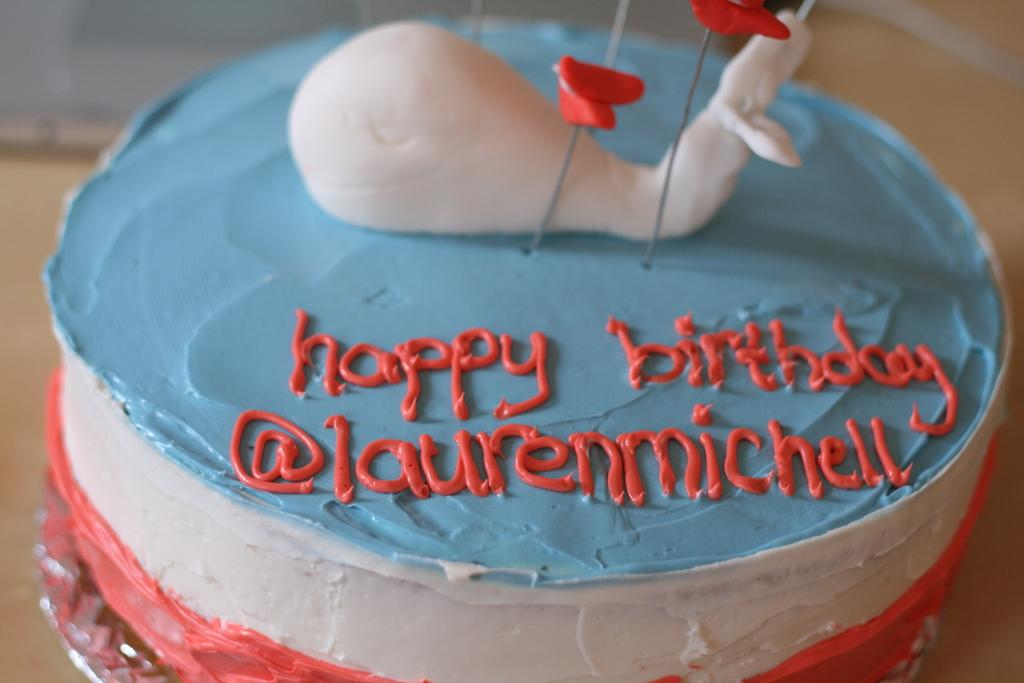What is the main subject of the image? There is a colorful cake in the image. How is the cake positioned in the image? The cake is on a platform. Can you describe the background of the image? The background of the image is blurry. What type of curtain is hanging near the cake in the image? There is no curtain present in the image. How many socks are visible on the cake in the image? There are no socks visible on the cake in the image. 